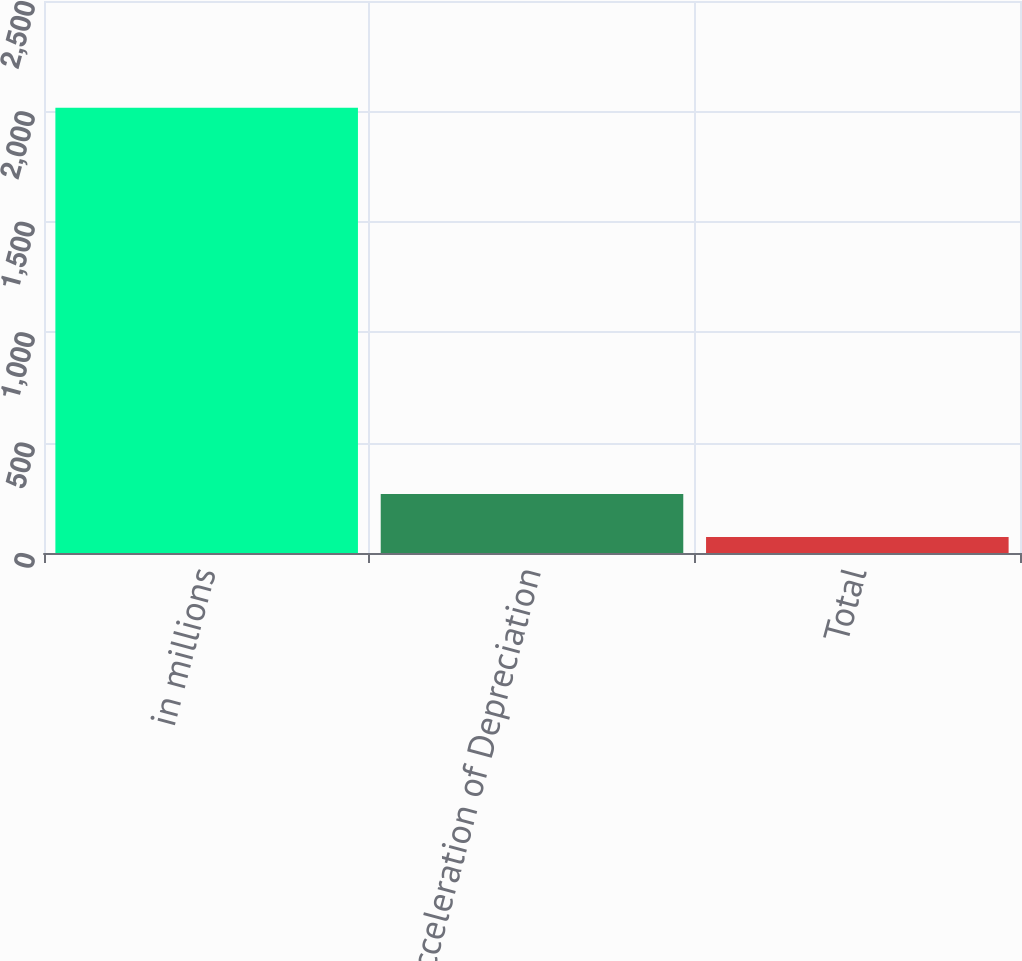<chart> <loc_0><loc_0><loc_500><loc_500><bar_chart><fcel>in millions<fcel>Acceleration of Depreciation<fcel>Total<nl><fcel>2017<fcel>267.4<fcel>73<nl></chart> 